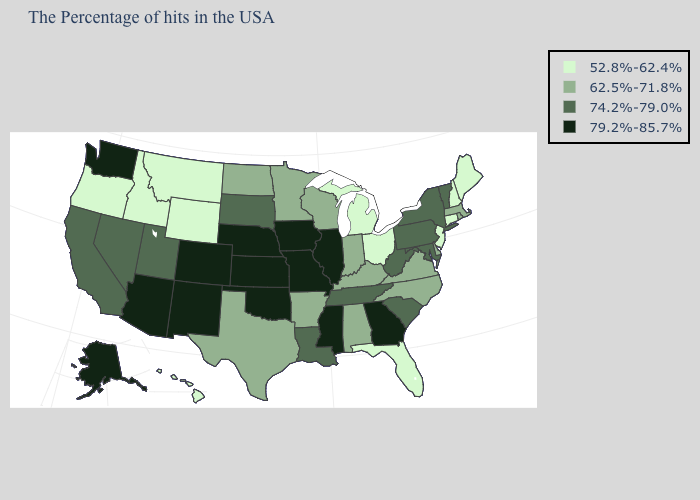What is the value of Maryland?
Be succinct. 74.2%-79.0%. Name the states that have a value in the range 52.8%-62.4%?
Give a very brief answer. Maine, New Hampshire, Connecticut, New Jersey, Ohio, Florida, Michigan, Wyoming, Montana, Idaho, Oregon, Hawaii. Is the legend a continuous bar?
Quick response, please. No. Name the states that have a value in the range 62.5%-71.8%?
Write a very short answer. Massachusetts, Rhode Island, Delaware, Virginia, North Carolina, Kentucky, Indiana, Alabama, Wisconsin, Arkansas, Minnesota, Texas, North Dakota. Which states have the highest value in the USA?
Quick response, please. Georgia, Illinois, Mississippi, Missouri, Iowa, Kansas, Nebraska, Oklahoma, Colorado, New Mexico, Arizona, Washington, Alaska. Does Iowa have a lower value than Kentucky?
Be succinct. No. What is the value of Hawaii?
Keep it brief. 52.8%-62.4%. How many symbols are there in the legend?
Give a very brief answer. 4. Does Oregon have the lowest value in the USA?
Short answer required. Yes. What is the value of Minnesota?
Answer briefly. 62.5%-71.8%. What is the value of Georgia?
Short answer required. 79.2%-85.7%. What is the value of North Carolina?
Short answer required. 62.5%-71.8%. Does the map have missing data?
Give a very brief answer. No. Name the states that have a value in the range 79.2%-85.7%?
Keep it brief. Georgia, Illinois, Mississippi, Missouri, Iowa, Kansas, Nebraska, Oklahoma, Colorado, New Mexico, Arizona, Washington, Alaska. Name the states that have a value in the range 52.8%-62.4%?
Answer briefly. Maine, New Hampshire, Connecticut, New Jersey, Ohio, Florida, Michigan, Wyoming, Montana, Idaho, Oregon, Hawaii. 